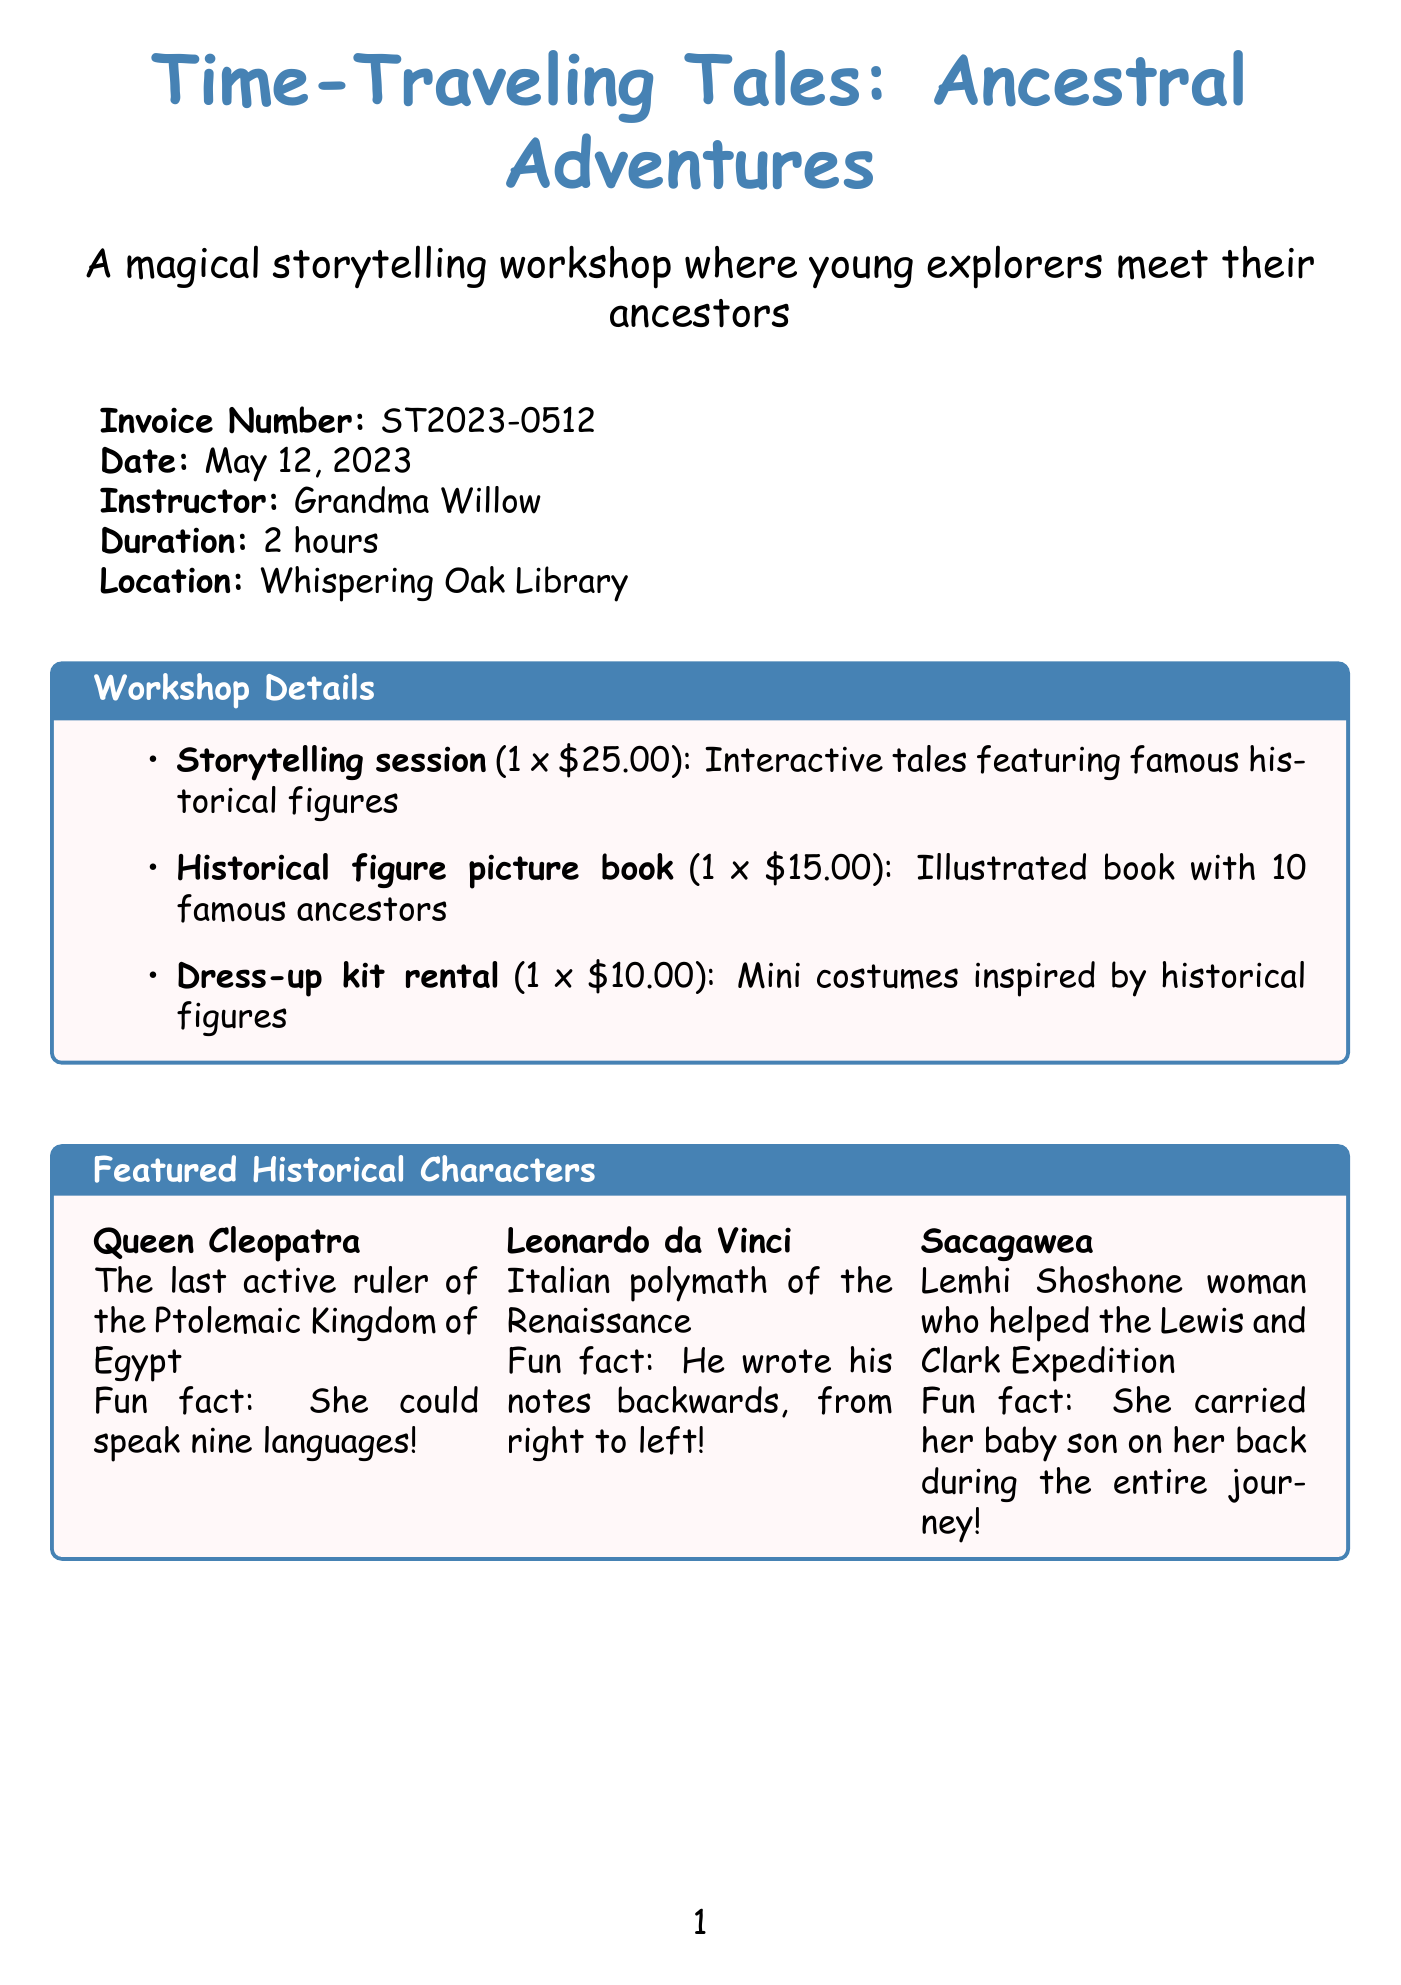What is the invoice number? The invoice number is a unique identifier for this document.
Answer: ST2023-0512 Who is the instructor? The instructor is the person leading the workshop.
Answer: Grandma Willow What is the total amount? The total amount is the final amount due for the workshop.
Answer: $50.00 How long is the workshop? The duration indicates how long the workshop will take place.
Answer: 2 hours What is one payment method accepted? The document lists different payment methods that can be used.
Answer: Magic beans What special note is mentioned about bringing something? This detail highlights an activity for participants during the workshop.
Answer: Bring your favorite stuffed animal Which historical figure could speak nine languages? This question asks for specific information about one of the featured characters.
Answer: Queen Cleopatra What is the location of the workshop? The location provides the venue for the event described.
Answer: Whispering Oak Library What is featured in the historical figure picture book? This detail describes the content of the book included in the workshop.
Answer: 10 famous ancestors 